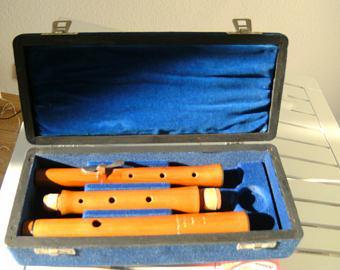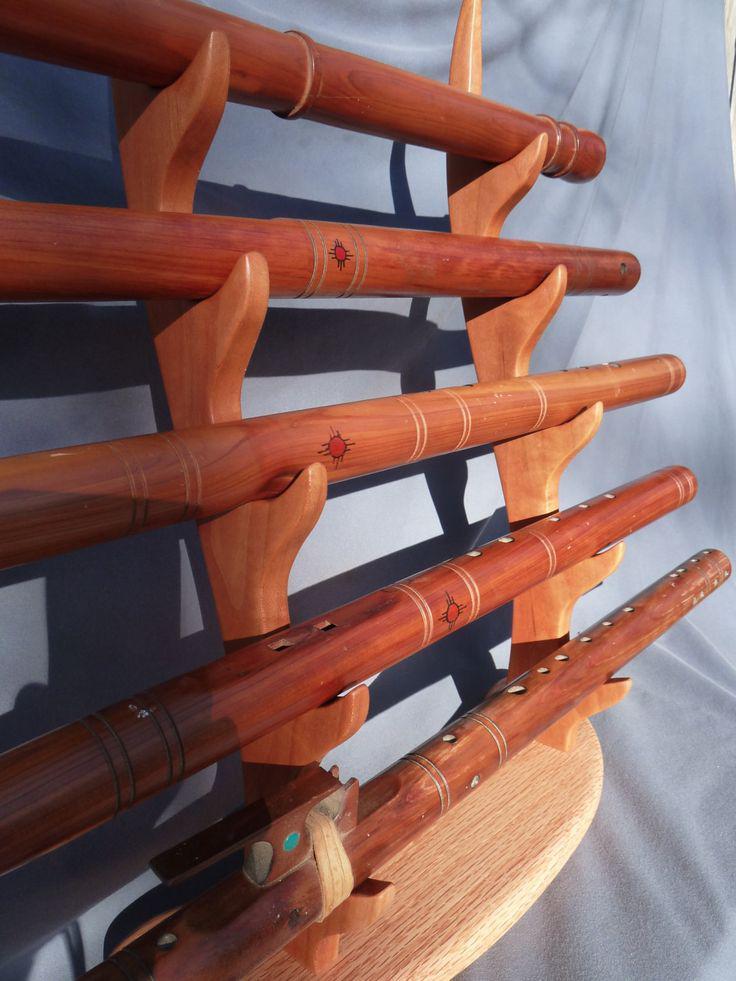The first image is the image on the left, the second image is the image on the right. For the images displayed, is the sentence "Five wooden flutes are displayed horizontally on a stand." factually correct? Answer yes or no. Yes. The first image is the image on the left, the second image is the image on the right. Given the left and right images, does the statement "One of the images shows a two-piece flute, on a stand, apart." hold true? Answer yes or no. No. 